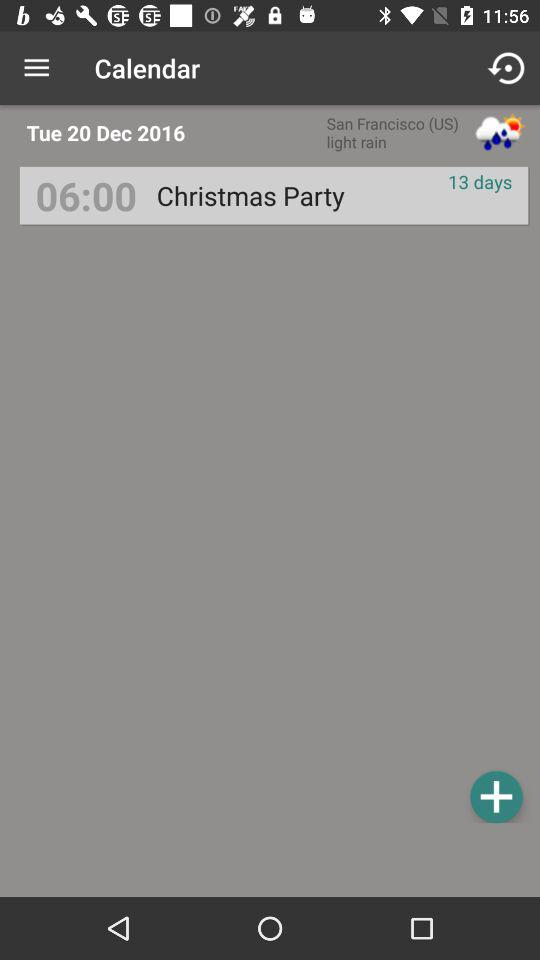What is the day of the given date? The day is Tuesday. 